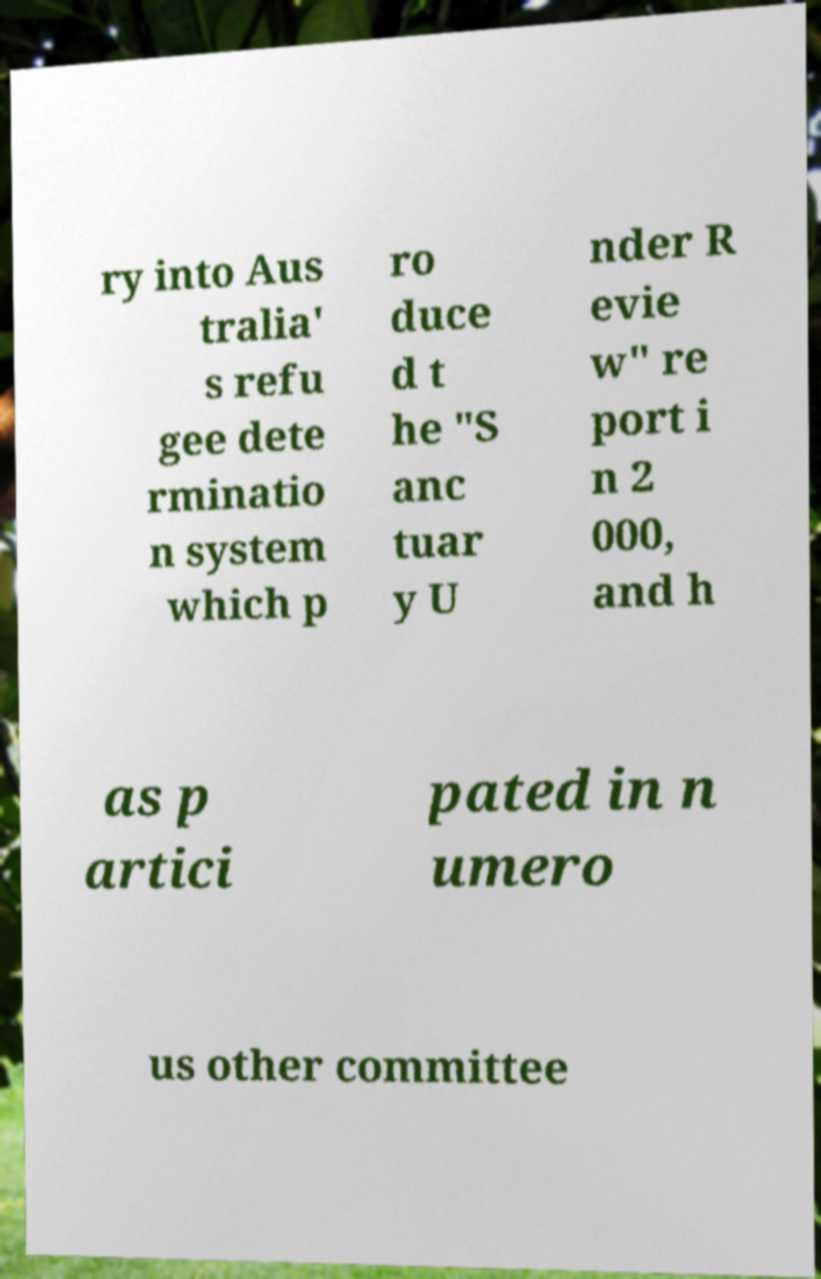Please read and relay the text visible in this image. What does it say? ry into Aus tralia' s refu gee dete rminatio n system which p ro duce d t he "S anc tuar y U nder R evie w" re port i n 2 000, and h as p artici pated in n umero us other committee 